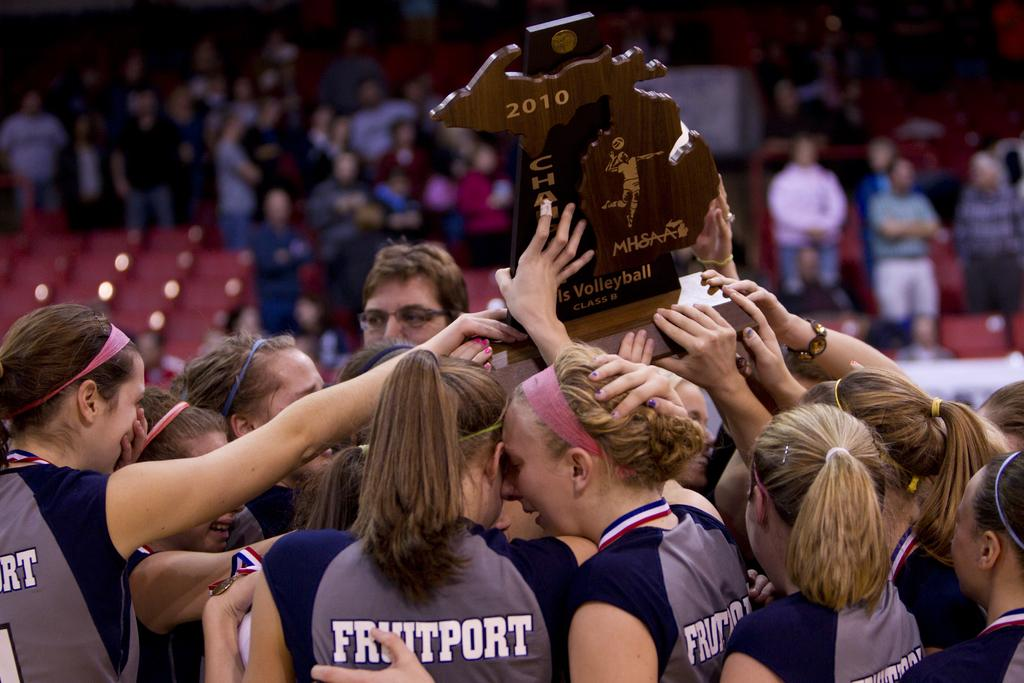Provide a one-sentence caption for the provided image. Women holding up a basketball trophy and are wearing "Fruitport" jerseys. 